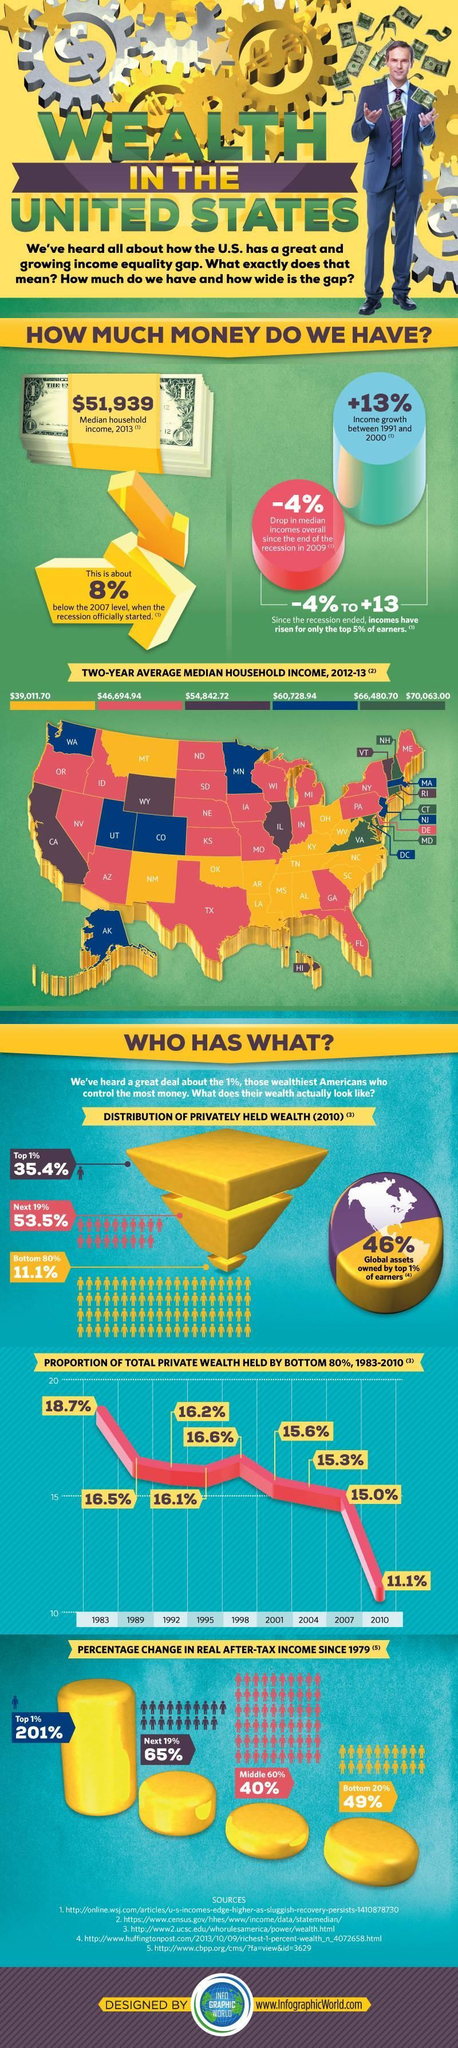How much of global assets do top 1% earners own?
Answer the question with a short phrase. 46% What is the two-year average median household income amount denoted by the color blue? $60,728.94 What is Median household income for 2013? $51,939 What is the two-year average median household income for TX? $46,694.94 How many states have median household income above $66,480.70? 4 By what percentage is 2013 median household income lower than 2007? 8% What is the two-year average median household income for CA? $54,842.72 